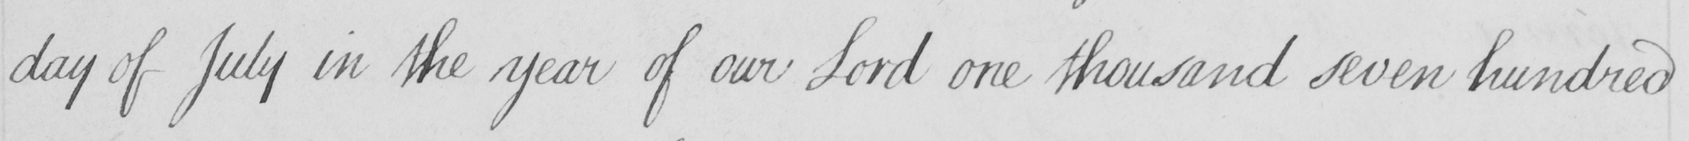Can you tell me what this handwritten text says? day of July in the year of our Lord one thousand seven hundred 